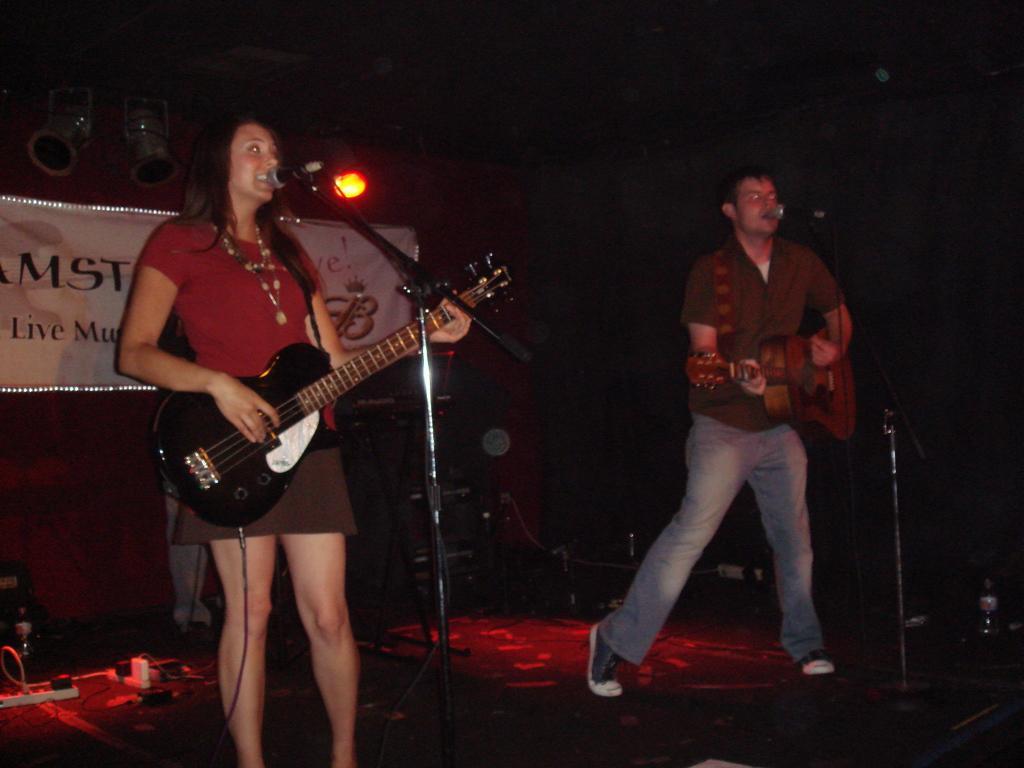Describe this image in one or two sentences. a person is playing guitar at the left side wearing a red t shirt. at the right there is a person wearing green t shirt and jeans and playing guitar and singing. behind them there is a banner on which live music is written. 